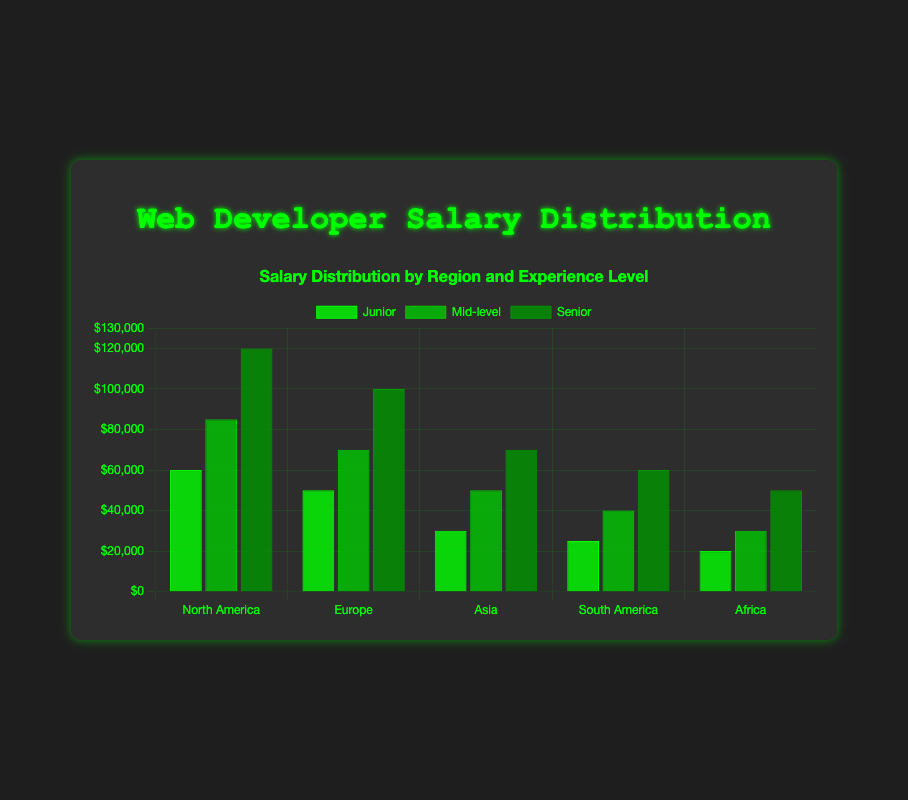What is the average salary for Senior developers across all regions? First, add up the salary values for Senior developers across all regions: 120000 (North America) + 100000 (Europe) + 70000 (Asia) + 60000 (South America) + 50000 (Africa). The total sum is 400000. Then, divide this sum by the number of regions (5) to get the average: 400000 / 5 = 80000.
Answer: 80000 Which region has the highest salary for Junior developers? By comparing the Junior developer salaries for all regions: 60000 (North America), 50000 (Europe), 30000 (Asia), 25000 (South America), and 20000 (Africa), we see that the highest salary is in North America.
Answer: North America Is the salary difference between Junior and Senior developers in Europe greater than the same difference in Asia? For Europe, the salary difference is 100000 (Senior) - 50000 (Junior) = 50000. For Asia, the salary difference is 70000 (Senior) - 30000 (Junior) = 40000. Therefore, the difference in Europe (50000) is greater than in Asia (40000).
Answer: Yes Between which two experience levels is the salary difference the smallest in North America? The salary differences for North America are: Mid-level - Junior = 85000 - 60000 = 25000, and Senior - Mid-level = 120000 - 85000 = 35000. Therefore, the smallest salary difference is between Junior and Mid-level.
Answer: Junior and Mid-level Which region has the smallest gap between Junior and Mid-level developer salaries? Calculate the differences: North America: 85000 - 60000 = 25000, Europe: 70000 - 50000 = 20000, Asia: 50000 - 30000 = 20000, South America: 40000 - 25000 = 15000, Africa: 30000 - 20000 = 10000. The smallest gap is in Africa with 10000.
Answer: Africa What is the total salary for all experience levels combined in South America? Sum the salaries of Junior, Mid-level, and Senior developers in South America: 25000 + 40000 + 60000 = 125000.
Answer: 125000 Which experience level has the most uniform salary distribution across all regions (i.e., the smallest range)? Calculate the salary ranges: Junior: max (60000) - min (20000) = 40000, Mid-level: max (85000) - min (30000) = 55000, Senior: max (120000) - min (50000) = 70000. The smallest range is for Junior developers with 40000.
Answer: Junior What is the salary difference between the highest-paid Senior developer and the lowest-paid Junior developer? The highest-paid Senior developer earns 120000 (North America), and the lowest-paid Junior developer earns 20000 (Africa). The difference is 120000 - 20000 = 100000.
Answer: 100000 